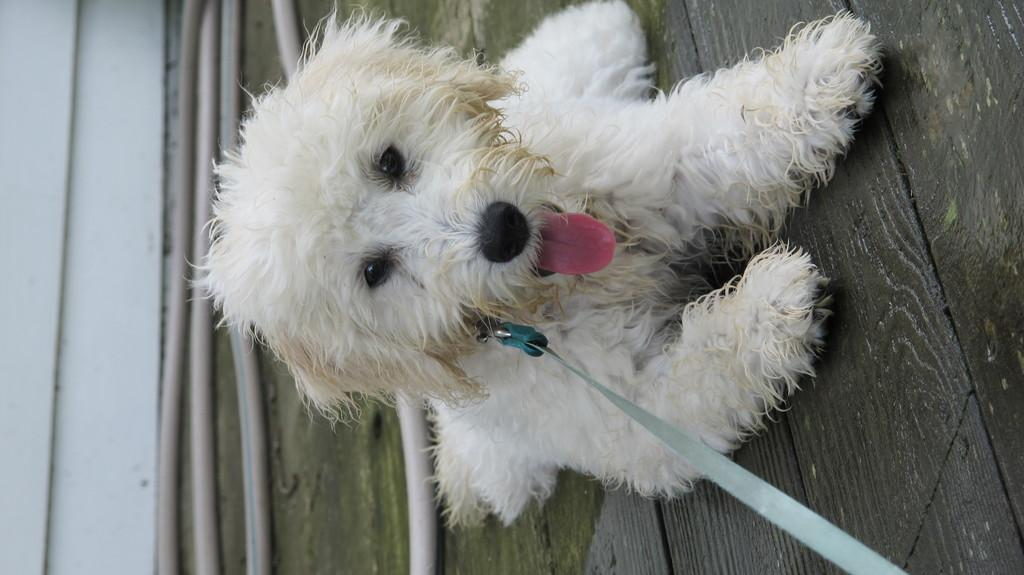What type of animal is present in the image? There is a dog in the image. Can you describe the background of the image? There is a plastic pipe behind the dog. How many ducks are present in the image? There are no ducks present in the image; it only features a dog and a plastic pipe. 